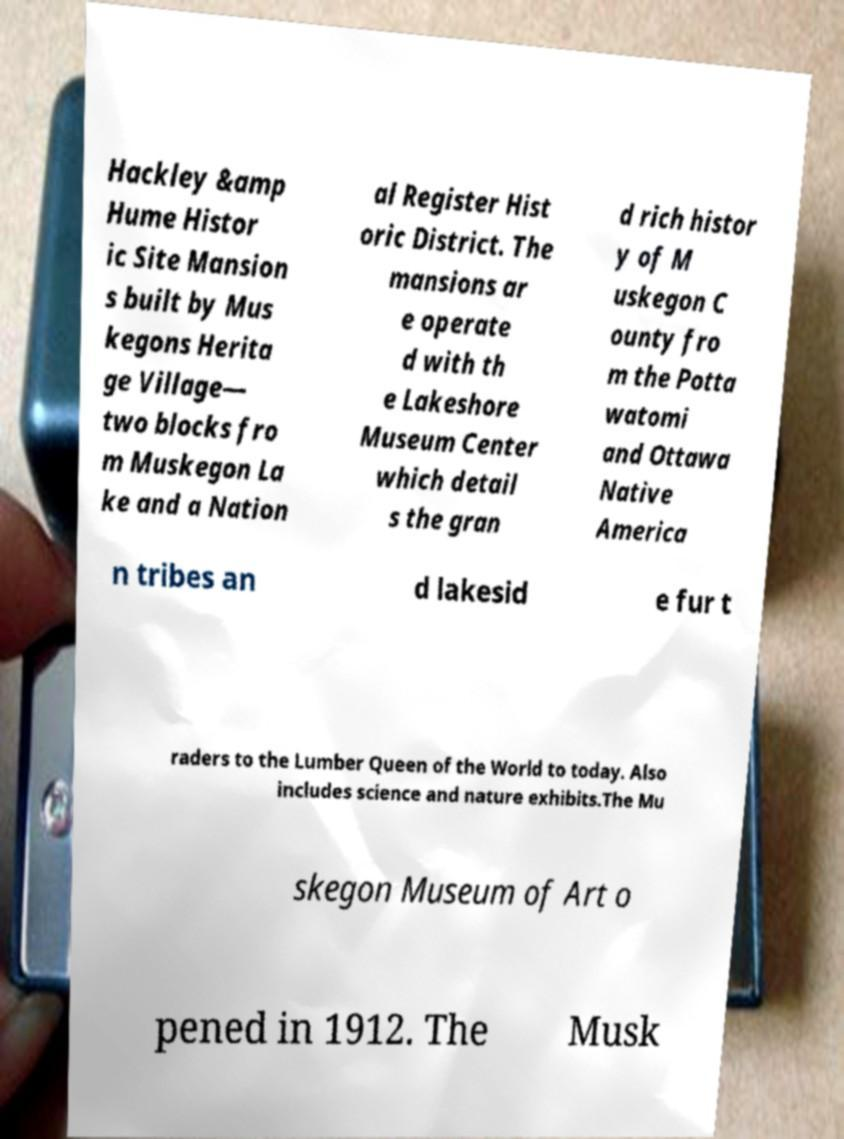Can you read and provide the text displayed in the image?This photo seems to have some interesting text. Can you extract and type it out for me? Hackley &amp Hume Histor ic Site Mansion s built by Mus kegons Herita ge Village— two blocks fro m Muskegon La ke and a Nation al Register Hist oric District. The mansions ar e operate d with th e Lakeshore Museum Center which detail s the gran d rich histor y of M uskegon C ounty fro m the Potta watomi and Ottawa Native America n tribes an d lakesid e fur t raders to the Lumber Queen of the World to today. Also includes science and nature exhibits.The Mu skegon Museum of Art o pened in 1912. The Musk 